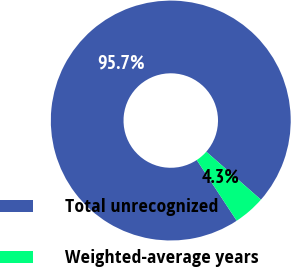Convert chart to OTSL. <chart><loc_0><loc_0><loc_500><loc_500><pie_chart><fcel>Total unrecognized<fcel>Weighted-average years<nl><fcel>95.73%<fcel>4.27%<nl></chart> 